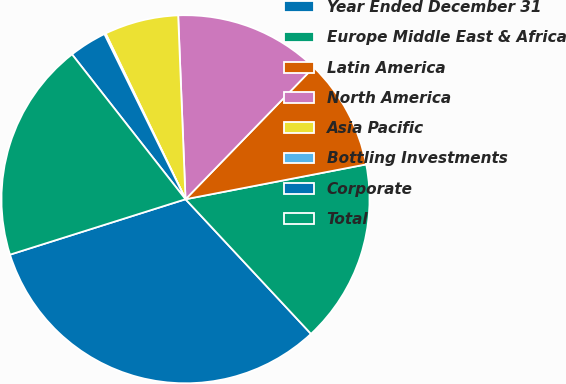Convert chart to OTSL. <chart><loc_0><loc_0><loc_500><loc_500><pie_chart><fcel>Year Ended December 31<fcel>Europe Middle East & Africa<fcel>Latin America<fcel>North America<fcel>Asia Pacific<fcel>Bottling Investments<fcel>Corporate<fcel>Total<nl><fcel>32.07%<fcel>16.09%<fcel>9.7%<fcel>12.9%<fcel>6.51%<fcel>0.12%<fcel>3.31%<fcel>19.29%<nl></chart> 